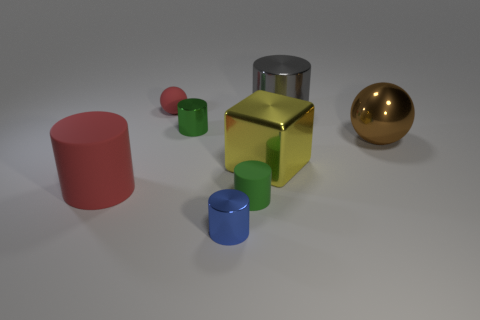Subtract all blue cylinders. How many cylinders are left? 4 Subtract all small green shiny cylinders. How many cylinders are left? 4 Subtract all gray cylinders. Subtract all cyan balls. How many cylinders are left? 4 Add 1 big brown metallic things. How many objects exist? 9 Subtract all cubes. How many objects are left? 7 Subtract 0 red cubes. How many objects are left? 8 Subtract all purple shiny spheres. Subtract all small spheres. How many objects are left? 7 Add 1 metallic balls. How many metallic balls are left? 2 Add 6 large metallic objects. How many large metallic objects exist? 9 